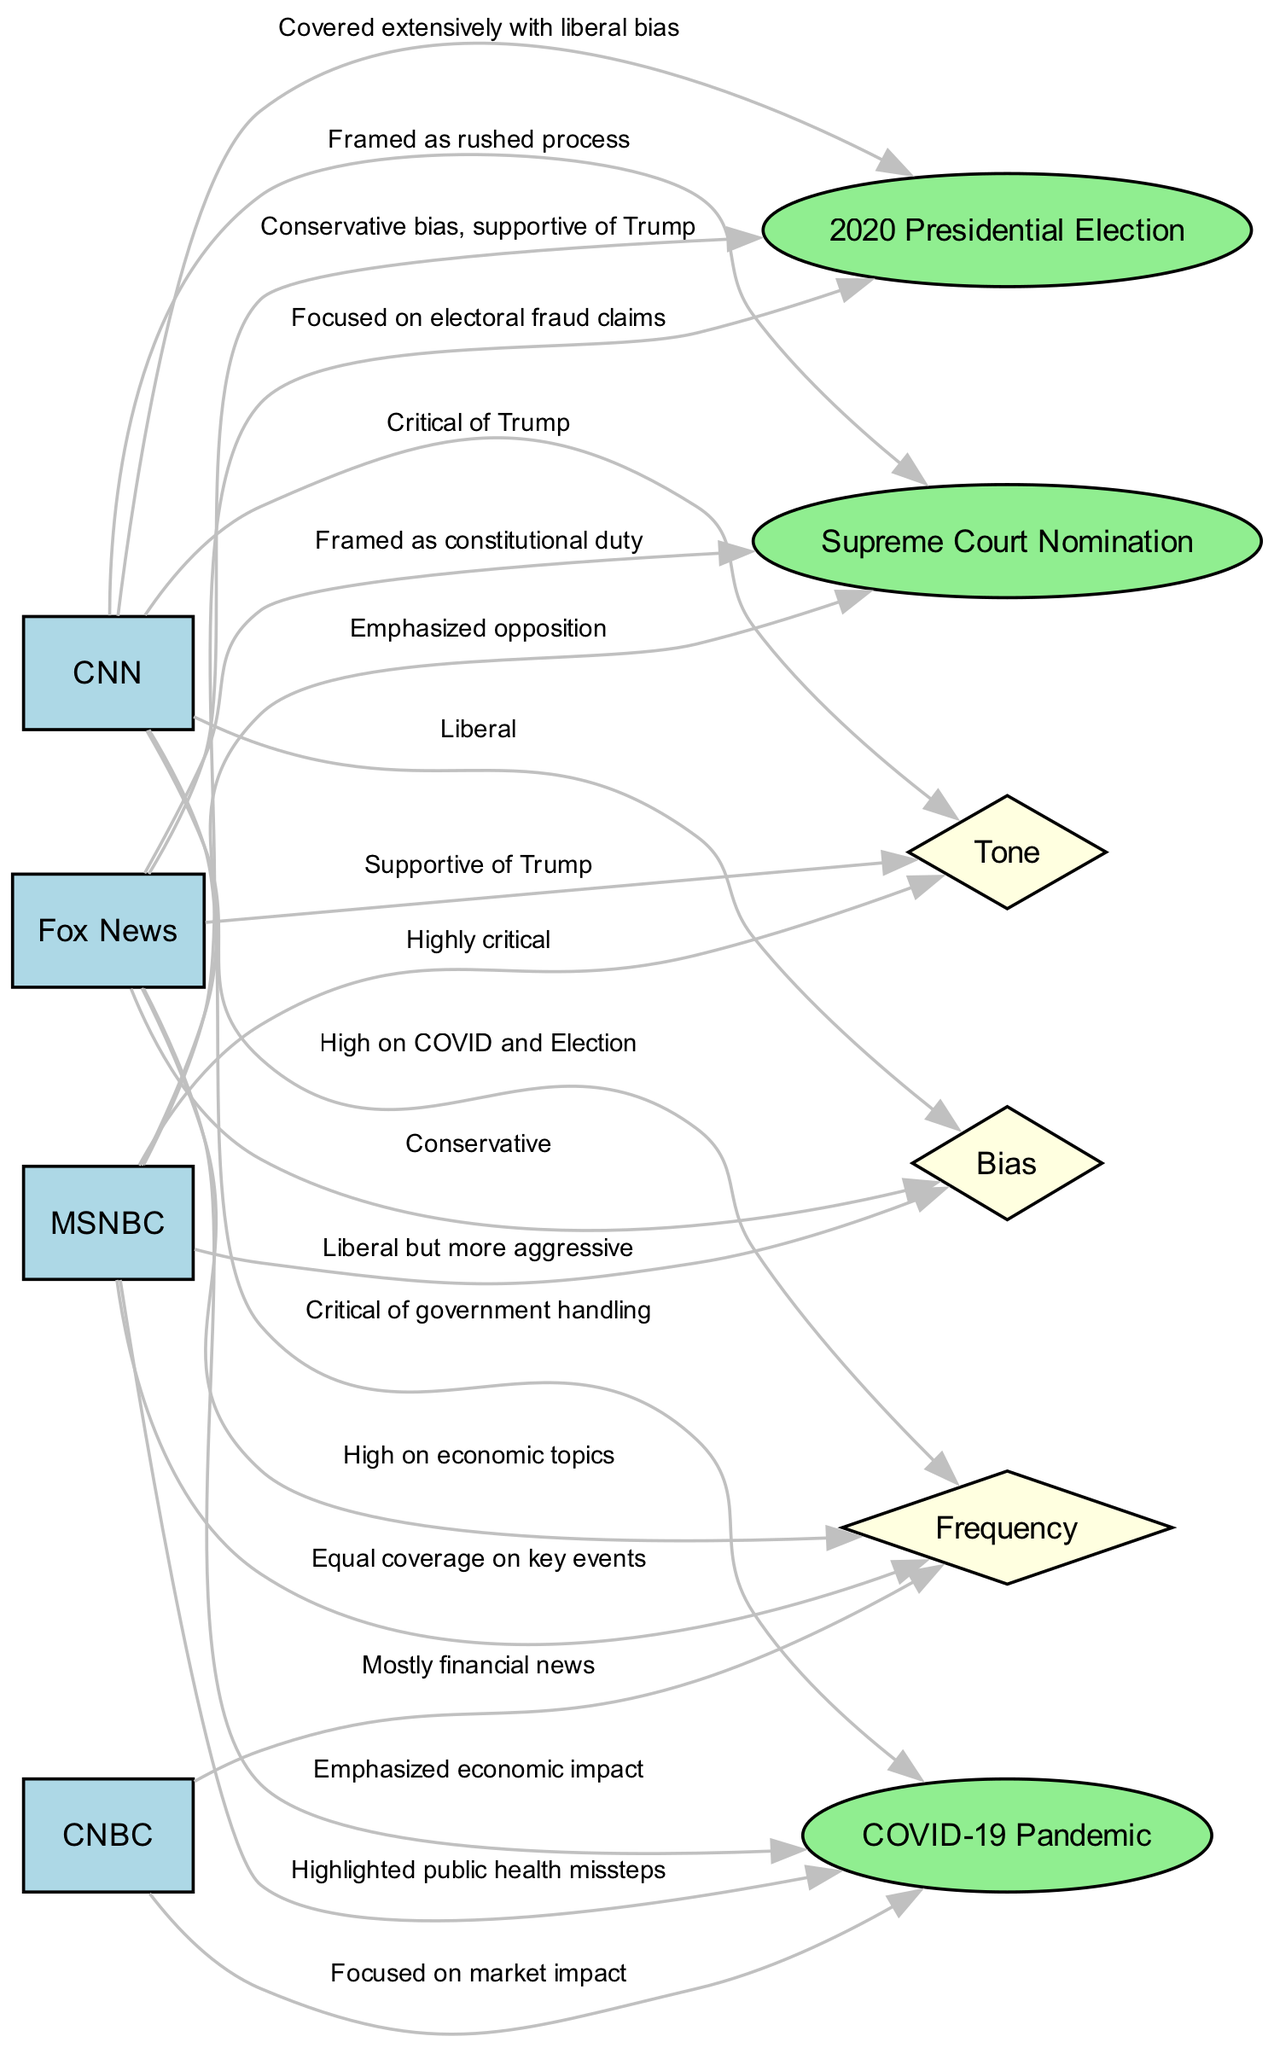What event does CNN cover extensively? The diagram states that CNN covers the "2020 Presidential Election" extensively with a liberal bias. This information is directly derived from the edge connecting CNN to the event node labeled "2020 Presidential Election."
Answer: 2020 Presidential Election What is the bias of Fox News? According to the diagram, Fox News is labeled as having a "Conservative" bias, as indicated by the edge connecting Fox News to the Bias node.
Answer: Conservative Which event is CNBC focused on? The diagram indicates that CNBC is focused on the "COVID-19 Pandemic" in the context of market impact, evidenced by the edge from CNBC leading to this event.
Answer: COVID-19 Pandemic How many major networks are covered in the diagram? The diagram lists four major networks: CNN, Fox News, MSNBC, and CNBC, which can be counted by observing the nodes classified as networks.
Answer: 4 What tone does MSNBC adopt towards the Supreme Court nomination? From the diagram, MSNBC's tone towards the Supreme Court nomination can be inferred as "Highly critical," which is conveyed through the edge linking MSNBC to the Tone node.
Answer: Highly critical Explain the frequency of coverage for CNN. The diagram shows that CNN has "High on COVID and Election" frequency, as indicated by the edge from CNN to the Frequency node. This indicates a significant amount of coverage directed towards these two key political events.
Answer: High on COVID and Election Which network emphasizes the economic impact of the COVID-19 pandemic? The diagram clarifies that Fox News emphasizes the "economic impact" of the COVID-19 Pandemic, shown by the edge that connects Fox News to this event.
Answer: Fox News What is the relationship between MSNBC and the event "Supreme Court Nomination"? The diagram indicates that MSNBC emphasizes opposition regarding the Supreme Court Nomination, as shown by the edge labeled with this information. This reflects MSNBC’s critical engagement with the event.
Answer: Emphasized opposition How do the networks' biases compare to the tone they adopt? To determine this, one needs to analyze the edges connecting each network to both the Bias and Tone nodes. CNN and MSNBC adopt critical tones (Critical of Trump and Highly critical) that relate to their liberal biases. Conversely, Fox News's tone is supportive of Trump, aligning with its conservative bias. This shows a correlation between a network's bias and the tone it opts to use in coverage.
Answer: Correlation exists 